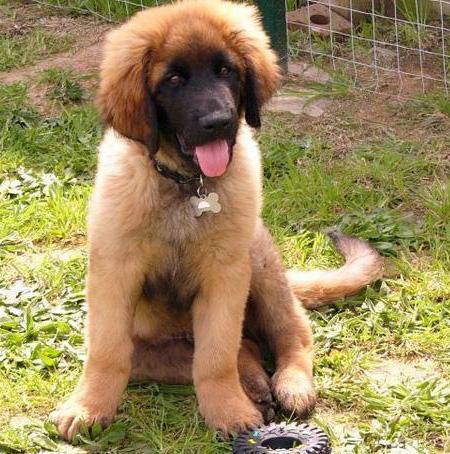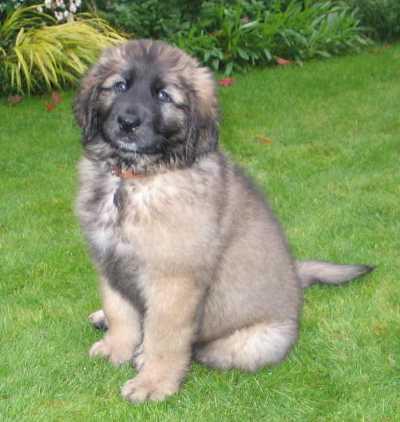The first image is the image on the left, the second image is the image on the right. For the images displayed, is the sentence "One image has a person standing next to a dog in the city." factually correct? Answer yes or no. No. The first image is the image on the left, the second image is the image on the right. Analyze the images presented: Is the assertion "In one of the images, a human can be seen walking at least one dog." valid? Answer yes or no. No. 